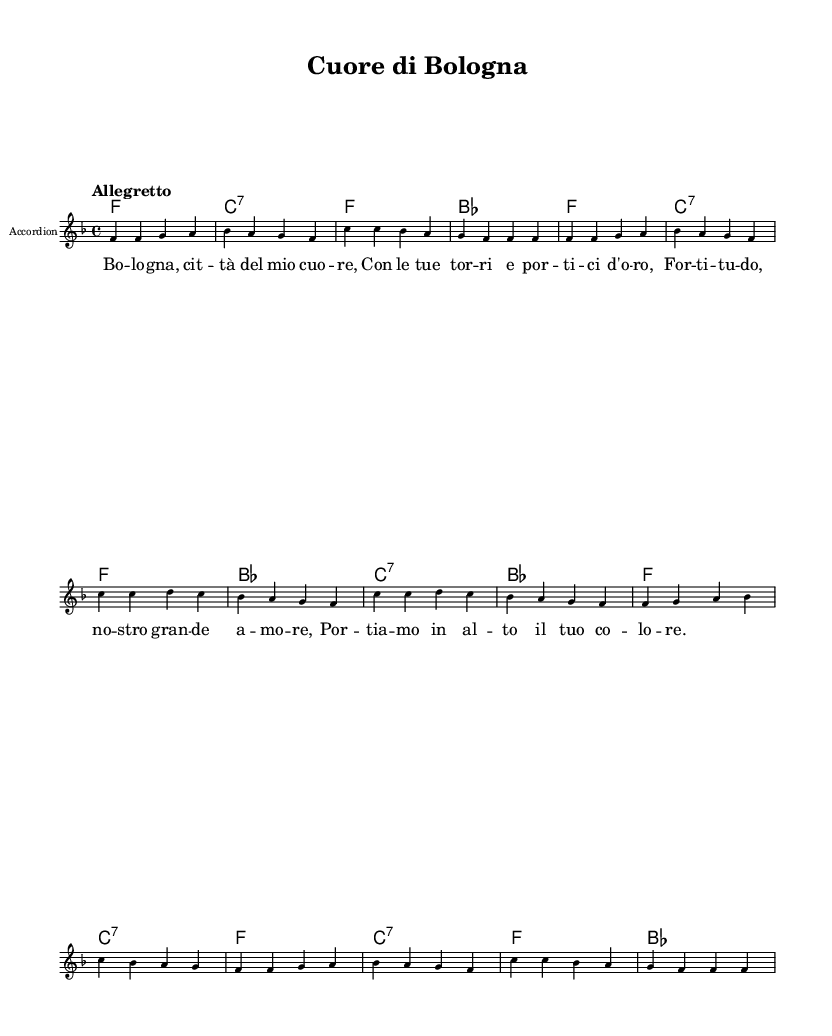What is the key signature of this music? The key signature is indicated by the placement of accidentals at the beginning of the staff. In this case, there is one flat (B♭) which shows that the key signature is F major.
Answer: F major What is the time signature of this music? The time signature is shown right after the key signature at the beginning of the sheet music, which indicates how many beats are in each measure. Here, it is 4/4, meaning there are 4 beats per measure.
Answer: 4/4 What is the tempo marking for this piece? The tempo is noted at the beginning of the music, specifying how fast it should be played. In this score, the tempo marking is "Allegretto," which indicates a moderate tempo.
Answer: Allegretto How many measures are in the melody? To find the number of measures, one can count the number of vertical bars that separate the music into distinct measures. In this piece, there are a total of 16 measures in the melody section.
Answer: 16 What instrument is specified in this arrangement? The instrument is indicated in the staff label, which denotes what instrument should perform the music. In this case, it is labeled "Accordion," indicating that the accordion is the intended instrument for this arrangement.
Answer: Accordion What is the highest note in the melody? To find the highest note, look for the note that is furthest up on the staff within the melody line. The highest note in this score is C, which is represented in the octave symbol ('), showing that it's a higher pitch.
Answer: C What is the lyrical theme of this song? The lyrics convey pride in the city of Bologna, celebrating its towers and golden doors, along with a deep love for Fortitudo Bologna. This theme evokes local heritage and pride in its origins, reflected in the lyrics of the song.
Answer: Pride in Bologna 